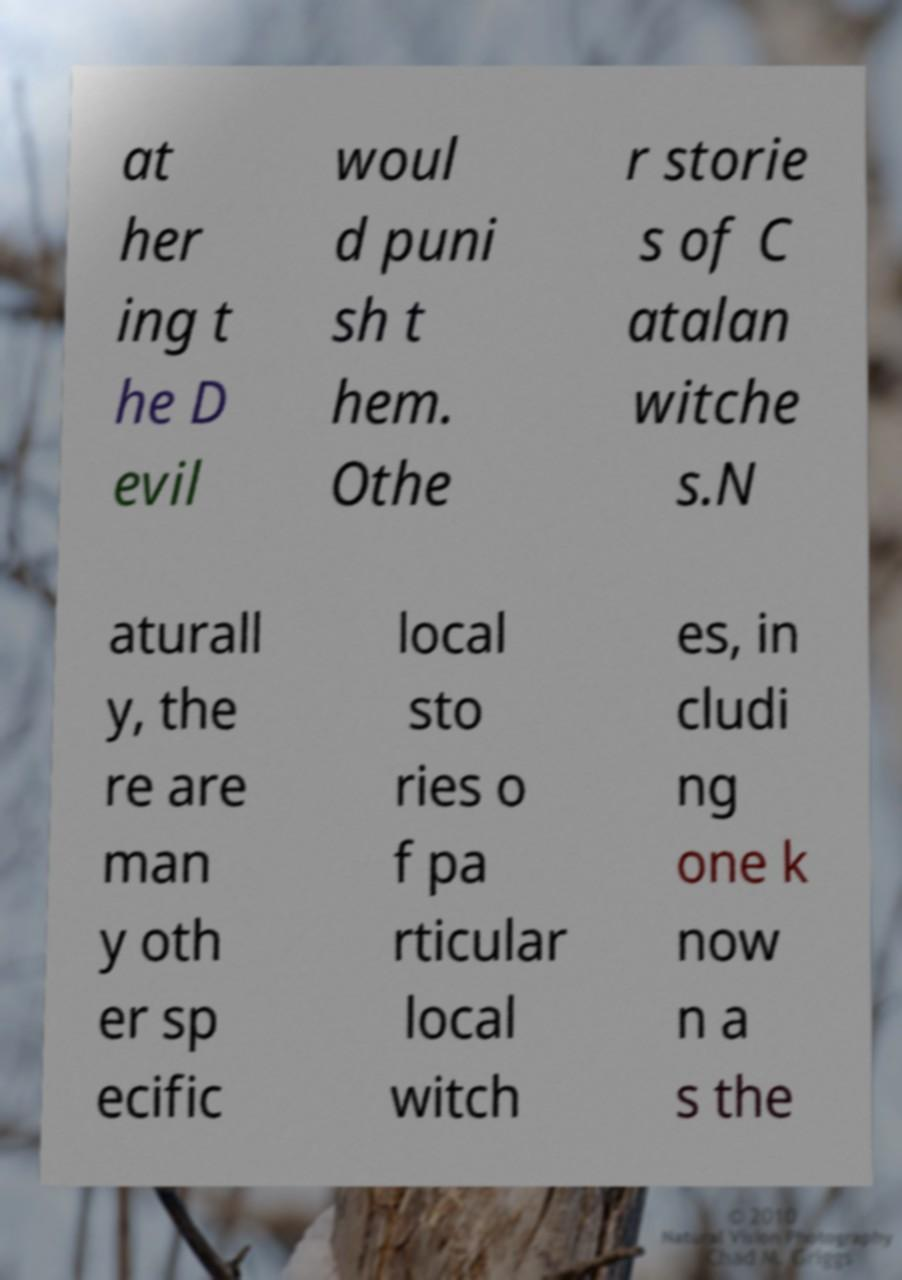Can you accurately transcribe the text from the provided image for me? at her ing t he D evil woul d puni sh t hem. Othe r storie s of C atalan witche s.N aturall y, the re are man y oth er sp ecific local sto ries o f pa rticular local witch es, in cludi ng one k now n a s the 